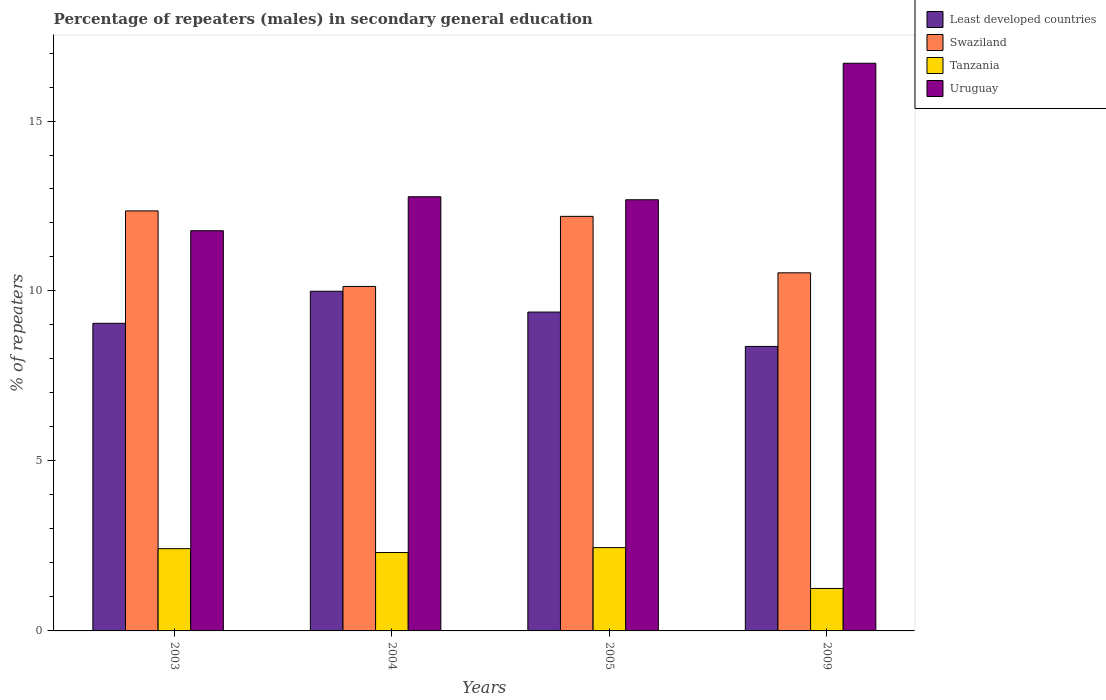How many different coloured bars are there?
Offer a terse response. 4. How many groups of bars are there?
Give a very brief answer. 4. Are the number of bars per tick equal to the number of legend labels?
Your response must be concise. Yes. How many bars are there on the 3rd tick from the right?
Offer a very short reply. 4. What is the label of the 1st group of bars from the left?
Your answer should be compact. 2003. In how many cases, is the number of bars for a given year not equal to the number of legend labels?
Provide a succinct answer. 0. What is the percentage of male repeaters in Least developed countries in 2009?
Give a very brief answer. 8.37. Across all years, what is the maximum percentage of male repeaters in Swaziland?
Ensure brevity in your answer.  12.36. Across all years, what is the minimum percentage of male repeaters in Least developed countries?
Ensure brevity in your answer.  8.37. What is the total percentage of male repeaters in Least developed countries in the graph?
Provide a succinct answer. 36.79. What is the difference between the percentage of male repeaters in Least developed countries in 2003 and that in 2005?
Your answer should be compact. -0.33. What is the difference between the percentage of male repeaters in Uruguay in 2003 and the percentage of male repeaters in Least developed countries in 2004?
Your response must be concise. 1.78. What is the average percentage of male repeaters in Swaziland per year?
Provide a succinct answer. 11.3. In the year 2003, what is the difference between the percentage of male repeaters in Least developed countries and percentage of male repeaters in Tanzania?
Your answer should be compact. 6.63. What is the ratio of the percentage of male repeaters in Uruguay in 2003 to that in 2004?
Make the answer very short. 0.92. Is the percentage of male repeaters in Least developed countries in 2003 less than that in 2009?
Give a very brief answer. No. Is the difference between the percentage of male repeaters in Least developed countries in 2004 and 2009 greater than the difference between the percentage of male repeaters in Tanzania in 2004 and 2009?
Make the answer very short. Yes. What is the difference between the highest and the second highest percentage of male repeaters in Tanzania?
Provide a succinct answer. 0.03. What is the difference between the highest and the lowest percentage of male repeaters in Least developed countries?
Offer a terse response. 1.62. In how many years, is the percentage of male repeaters in Tanzania greater than the average percentage of male repeaters in Tanzania taken over all years?
Keep it short and to the point. 3. What does the 1st bar from the left in 2005 represents?
Offer a terse response. Least developed countries. What does the 1st bar from the right in 2003 represents?
Provide a succinct answer. Uruguay. Is it the case that in every year, the sum of the percentage of male repeaters in Swaziland and percentage of male repeaters in Least developed countries is greater than the percentage of male repeaters in Uruguay?
Ensure brevity in your answer.  Yes. How many bars are there?
Your response must be concise. 16. What is the difference between two consecutive major ticks on the Y-axis?
Keep it short and to the point. 5. Does the graph contain any zero values?
Your answer should be compact. No. Does the graph contain grids?
Your answer should be very brief. No. Where does the legend appear in the graph?
Offer a very short reply. Top right. What is the title of the graph?
Make the answer very short. Percentage of repeaters (males) in secondary general education. What is the label or title of the Y-axis?
Your answer should be compact. % of repeaters. What is the % of repeaters of Least developed countries in 2003?
Ensure brevity in your answer.  9.05. What is the % of repeaters of Swaziland in 2003?
Offer a very short reply. 12.36. What is the % of repeaters of Tanzania in 2003?
Your answer should be compact. 2.42. What is the % of repeaters of Uruguay in 2003?
Your response must be concise. 11.77. What is the % of repeaters in Least developed countries in 2004?
Provide a short and direct response. 9.99. What is the % of repeaters of Swaziland in 2004?
Give a very brief answer. 10.13. What is the % of repeaters in Tanzania in 2004?
Provide a succinct answer. 2.31. What is the % of repeaters of Uruguay in 2004?
Make the answer very short. 12.77. What is the % of repeaters of Least developed countries in 2005?
Your answer should be very brief. 9.38. What is the % of repeaters in Swaziland in 2005?
Your response must be concise. 12.2. What is the % of repeaters in Tanzania in 2005?
Keep it short and to the point. 2.45. What is the % of repeaters in Uruguay in 2005?
Provide a short and direct response. 12.68. What is the % of repeaters of Least developed countries in 2009?
Make the answer very short. 8.37. What is the % of repeaters of Swaziland in 2009?
Give a very brief answer. 10.53. What is the % of repeaters of Tanzania in 2009?
Your answer should be very brief. 1.25. What is the % of repeaters in Uruguay in 2009?
Your answer should be compact. 16.7. Across all years, what is the maximum % of repeaters of Least developed countries?
Provide a short and direct response. 9.99. Across all years, what is the maximum % of repeaters in Swaziland?
Provide a succinct answer. 12.36. Across all years, what is the maximum % of repeaters in Tanzania?
Offer a terse response. 2.45. Across all years, what is the maximum % of repeaters in Uruguay?
Make the answer very short. 16.7. Across all years, what is the minimum % of repeaters of Least developed countries?
Offer a terse response. 8.37. Across all years, what is the minimum % of repeaters of Swaziland?
Offer a very short reply. 10.13. Across all years, what is the minimum % of repeaters of Tanzania?
Your answer should be compact. 1.25. Across all years, what is the minimum % of repeaters in Uruguay?
Give a very brief answer. 11.77. What is the total % of repeaters of Least developed countries in the graph?
Make the answer very short. 36.79. What is the total % of repeaters of Swaziland in the graph?
Ensure brevity in your answer.  45.22. What is the total % of repeaters of Tanzania in the graph?
Ensure brevity in your answer.  8.42. What is the total % of repeaters of Uruguay in the graph?
Offer a very short reply. 53.93. What is the difference between the % of repeaters in Least developed countries in 2003 and that in 2004?
Ensure brevity in your answer.  -0.94. What is the difference between the % of repeaters in Swaziland in 2003 and that in 2004?
Keep it short and to the point. 2.22. What is the difference between the % of repeaters in Tanzania in 2003 and that in 2004?
Make the answer very short. 0.11. What is the difference between the % of repeaters in Uruguay in 2003 and that in 2004?
Offer a terse response. -1. What is the difference between the % of repeaters in Least developed countries in 2003 and that in 2005?
Your answer should be very brief. -0.33. What is the difference between the % of repeaters of Swaziland in 2003 and that in 2005?
Ensure brevity in your answer.  0.16. What is the difference between the % of repeaters in Tanzania in 2003 and that in 2005?
Your answer should be very brief. -0.03. What is the difference between the % of repeaters of Uruguay in 2003 and that in 2005?
Provide a short and direct response. -0.91. What is the difference between the % of repeaters of Least developed countries in 2003 and that in 2009?
Provide a succinct answer. 0.68. What is the difference between the % of repeaters of Swaziland in 2003 and that in 2009?
Ensure brevity in your answer.  1.82. What is the difference between the % of repeaters of Tanzania in 2003 and that in 2009?
Offer a very short reply. 1.17. What is the difference between the % of repeaters of Uruguay in 2003 and that in 2009?
Provide a succinct answer. -4.93. What is the difference between the % of repeaters of Least developed countries in 2004 and that in 2005?
Your answer should be compact. 0.61. What is the difference between the % of repeaters of Swaziland in 2004 and that in 2005?
Your answer should be compact. -2.06. What is the difference between the % of repeaters in Tanzania in 2004 and that in 2005?
Your answer should be very brief. -0.14. What is the difference between the % of repeaters of Uruguay in 2004 and that in 2005?
Give a very brief answer. 0.09. What is the difference between the % of repeaters in Least developed countries in 2004 and that in 2009?
Offer a very short reply. 1.62. What is the difference between the % of repeaters in Swaziland in 2004 and that in 2009?
Provide a short and direct response. -0.4. What is the difference between the % of repeaters in Tanzania in 2004 and that in 2009?
Ensure brevity in your answer.  1.06. What is the difference between the % of repeaters in Uruguay in 2004 and that in 2009?
Give a very brief answer. -3.93. What is the difference between the % of repeaters of Least developed countries in 2005 and that in 2009?
Offer a terse response. 1.01. What is the difference between the % of repeaters of Swaziland in 2005 and that in 2009?
Your answer should be compact. 1.66. What is the difference between the % of repeaters of Tanzania in 2005 and that in 2009?
Your answer should be very brief. 1.2. What is the difference between the % of repeaters in Uruguay in 2005 and that in 2009?
Provide a short and direct response. -4.02. What is the difference between the % of repeaters in Least developed countries in 2003 and the % of repeaters in Swaziland in 2004?
Keep it short and to the point. -1.08. What is the difference between the % of repeaters in Least developed countries in 2003 and the % of repeaters in Tanzania in 2004?
Keep it short and to the point. 6.74. What is the difference between the % of repeaters in Least developed countries in 2003 and the % of repeaters in Uruguay in 2004?
Your response must be concise. -3.72. What is the difference between the % of repeaters of Swaziland in 2003 and the % of repeaters of Tanzania in 2004?
Your response must be concise. 10.05. What is the difference between the % of repeaters in Swaziland in 2003 and the % of repeaters in Uruguay in 2004?
Keep it short and to the point. -0.42. What is the difference between the % of repeaters of Tanzania in 2003 and the % of repeaters of Uruguay in 2004?
Your response must be concise. -10.35. What is the difference between the % of repeaters of Least developed countries in 2003 and the % of repeaters of Swaziland in 2005?
Keep it short and to the point. -3.15. What is the difference between the % of repeaters of Least developed countries in 2003 and the % of repeaters of Tanzania in 2005?
Your answer should be very brief. 6.6. What is the difference between the % of repeaters in Least developed countries in 2003 and the % of repeaters in Uruguay in 2005?
Keep it short and to the point. -3.63. What is the difference between the % of repeaters in Swaziland in 2003 and the % of repeaters in Tanzania in 2005?
Your answer should be compact. 9.91. What is the difference between the % of repeaters in Swaziland in 2003 and the % of repeaters in Uruguay in 2005?
Make the answer very short. -0.33. What is the difference between the % of repeaters in Tanzania in 2003 and the % of repeaters in Uruguay in 2005?
Give a very brief answer. -10.26. What is the difference between the % of repeaters of Least developed countries in 2003 and the % of repeaters of Swaziland in 2009?
Offer a very short reply. -1.49. What is the difference between the % of repeaters of Least developed countries in 2003 and the % of repeaters of Tanzania in 2009?
Give a very brief answer. 7.8. What is the difference between the % of repeaters of Least developed countries in 2003 and the % of repeaters of Uruguay in 2009?
Provide a succinct answer. -7.65. What is the difference between the % of repeaters of Swaziland in 2003 and the % of repeaters of Tanzania in 2009?
Your response must be concise. 11.11. What is the difference between the % of repeaters in Swaziland in 2003 and the % of repeaters in Uruguay in 2009?
Give a very brief answer. -4.34. What is the difference between the % of repeaters of Tanzania in 2003 and the % of repeaters of Uruguay in 2009?
Keep it short and to the point. -14.28. What is the difference between the % of repeaters of Least developed countries in 2004 and the % of repeaters of Swaziland in 2005?
Your answer should be very brief. -2.2. What is the difference between the % of repeaters in Least developed countries in 2004 and the % of repeaters in Tanzania in 2005?
Your response must be concise. 7.54. What is the difference between the % of repeaters in Least developed countries in 2004 and the % of repeaters in Uruguay in 2005?
Make the answer very short. -2.69. What is the difference between the % of repeaters of Swaziland in 2004 and the % of repeaters of Tanzania in 2005?
Ensure brevity in your answer.  7.68. What is the difference between the % of repeaters in Swaziland in 2004 and the % of repeaters in Uruguay in 2005?
Your response must be concise. -2.55. What is the difference between the % of repeaters of Tanzania in 2004 and the % of repeaters of Uruguay in 2005?
Offer a terse response. -10.38. What is the difference between the % of repeaters of Least developed countries in 2004 and the % of repeaters of Swaziland in 2009?
Ensure brevity in your answer.  -0.54. What is the difference between the % of repeaters of Least developed countries in 2004 and the % of repeaters of Tanzania in 2009?
Give a very brief answer. 8.74. What is the difference between the % of repeaters of Least developed countries in 2004 and the % of repeaters of Uruguay in 2009?
Make the answer very short. -6.71. What is the difference between the % of repeaters in Swaziland in 2004 and the % of repeaters in Tanzania in 2009?
Your answer should be compact. 8.88. What is the difference between the % of repeaters in Swaziland in 2004 and the % of repeaters in Uruguay in 2009?
Provide a short and direct response. -6.57. What is the difference between the % of repeaters in Tanzania in 2004 and the % of repeaters in Uruguay in 2009?
Your answer should be very brief. -14.39. What is the difference between the % of repeaters of Least developed countries in 2005 and the % of repeaters of Swaziland in 2009?
Give a very brief answer. -1.15. What is the difference between the % of repeaters of Least developed countries in 2005 and the % of repeaters of Tanzania in 2009?
Give a very brief answer. 8.13. What is the difference between the % of repeaters of Least developed countries in 2005 and the % of repeaters of Uruguay in 2009?
Give a very brief answer. -7.32. What is the difference between the % of repeaters in Swaziland in 2005 and the % of repeaters in Tanzania in 2009?
Offer a very short reply. 10.95. What is the difference between the % of repeaters of Swaziland in 2005 and the % of repeaters of Uruguay in 2009?
Your answer should be compact. -4.5. What is the difference between the % of repeaters in Tanzania in 2005 and the % of repeaters in Uruguay in 2009?
Give a very brief answer. -14.25. What is the average % of repeaters in Least developed countries per year?
Your response must be concise. 9.2. What is the average % of repeaters in Swaziland per year?
Your answer should be very brief. 11.3. What is the average % of repeaters of Tanzania per year?
Provide a short and direct response. 2.11. What is the average % of repeaters of Uruguay per year?
Provide a succinct answer. 13.48. In the year 2003, what is the difference between the % of repeaters in Least developed countries and % of repeaters in Swaziland?
Give a very brief answer. -3.31. In the year 2003, what is the difference between the % of repeaters in Least developed countries and % of repeaters in Tanzania?
Provide a short and direct response. 6.63. In the year 2003, what is the difference between the % of repeaters of Least developed countries and % of repeaters of Uruguay?
Ensure brevity in your answer.  -2.72. In the year 2003, what is the difference between the % of repeaters of Swaziland and % of repeaters of Tanzania?
Offer a very short reply. 9.94. In the year 2003, what is the difference between the % of repeaters of Swaziland and % of repeaters of Uruguay?
Your answer should be compact. 0.58. In the year 2003, what is the difference between the % of repeaters of Tanzania and % of repeaters of Uruguay?
Ensure brevity in your answer.  -9.35. In the year 2004, what is the difference between the % of repeaters of Least developed countries and % of repeaters of Swaziland?
Your answer should be compact. -0.14. In the year 2004, what is the difference between the % of repeaters of Least developed countries and % of repeaters of Tanzania?
Keep it short and to the point. 7.69. In the year 2004, what is the difference between the % of repeaters in Least developed countries and % of repeaters in Uruguay?
Your response must be concise. -2.78. In the year 2004, what is the difference between the % of repeaters of Swaziland and % of repeaters of Tanzania?
Your answer should be very brief. 7.83. In the year 2004, what is the difference between the % of repeaters of Swaziland and % of repeaters of Uruguay?
Your answer should be compact. -2.64. In the year 2004, what is the difference between the % of repeaters in Tanzania and % of repeaters in Uruguay?
Give a very brief answer. -10.47. In the year 2005, what is the difference between the % of repeaters in Least developed countries and % of repeaters in Swaziland?
Offer a very short reply. -2.82. In the year 2005, what is the difference between the % of repeaters in Least developed countries and % of repeaters in Tanzania?
Provide a succinct answer. 6.93. In the year 2005, what is the difference between the % of repeaters in Least developed countries and % of repeaters in Uruguay?
Offer a very short reply. -3.3. In the year 2005, what is the difference between the % of repeaters of Swaziland and % of repeaters of Tanzania?
Make the answer very short. 9.75. In the year 2005, what is the difference between the % of repeaters in Swaziland and % of repeaters in Uruguay?
Give a very brief answer. -0.49. In the year 2005, what is the difference between the % of repeaters in Tanzania and % of repeaters in Uruguay?
Your answer should be very brief. -10.23. In the year 2009, what is the difference between the % of repeaters of Least developed countries and % of repeaters of Swaziland?
Keep it short and to the point. -2.17. In the year 2009, what is the difference between the % of repeaters of Least developed countries and % of repeaters of Tanzania?
Your answer should be very brief. 7.12. In the year 2009, what is the difference between the % of repeaters in Least developed countries and % of repeaters in Uruguay?
Keep it short and to the point. -8.33. In the year 2009, what is the difference between the % of repeaters in Swaziland and % of repeaters in Tanzania?
Your answer should be compact. 9.29. In the year 2009, what is the difference between the % of repeaters in Swaziland and % of repeaters in Uruguay?
Give a very brief answer. -6.16. In the year 2009, what is the difference between the % of repeaters in Tanzania and % of repeaters in Uruguay?
Keep it short and to the point. -15.45. What is the ratio of the % of repeaters in Least developed countries in 2003 to that in 2004?
Give a very brief answer. 0.91. What is the ratio of the % of repeaters in Swaziland in 2003 to that in 2004?
Make the answer very short. 1.22. What is the ratio of the % of repeaters of Tanzania in 2003 to that in 2004?
Provide a succinct answer. 1.05. What is the ratio of the % of repeaters of Uruguay in 2003 to that in 2004?
Your answer should be very brief. 0.92. What is the ratio of the % of repeaters in Least developed countries in 2003 to that in 2005?
Offer a terse response. 0.96. What is the ratio of the % of repeaters of Swaziland in 2003 to that in 2005?
Ensure brevity in your answer.  1.01. What is the ratio of the % of repeaters of Uruguay in 2003 to that in 2005?
Keep it short and to the point. 0.93. What is the ratio of the % of repeaters of Least developed countries in 2003 to that in 2009?
Your answer should be compact. 1.08. What is the ratio of the % of repeaters of Swaziland in 2003 to that in 2009?
Keep it short and to the point. 1.17. What is the ratio of the % of repeaters of Tanzania in 2003 to that in 2009?
Your response must be concise. 1.94. What is the ratio of the % of repeaters of Uruguay in 2003 to that in 2009?
Offer a very short reply. 0.7. What is the ratio of the % of repeaters in Least developed countries in 2004 to that in 2005?
Ensure brevity in your answer.  1.07. What is the ratio of the % of repeaters of Swaziland in 2004 to that in 2005?
Offer a very short reply. 0.83. What is the ratio of the % of repeaters of Tanzania in 2004 to that in 2005?
Keep it short and to the point. 0.94. What is the ratio of the % of repeaters of Least developed countries in 2004 to that in 2009?
Keep it short and to the point. 1.19. What is the ratio of the % of repeaters of Swaziland in 2004 to that in 2009?
Your answer should be compact. 0.96. What is the ratio of the % of repeaters of Tanzania in 2004 to that in 2009?
Provide a succinct answer. 1.85. What is the ratio of the % of repeaters in Uruguay in 2004 to that in 2009?
Ensure brevity in your answer.  0.76. What is the ratio of the % of repeaters in Least developed countries in 2005 to that in 2009?
Give a very brief answer. 1.12. What is the ratio of the % of repeaters of Swaziland in 2005 to that in 2009?
Give a very brief answer. 1.16. What is the ratio of the % of repeaters in Tanzania in 2005 to that in 2009?
Offer a very short reply. 1.96. What is the ratio of the % of repeaters of Uruguay in 2005 to that in 2009?
Keep it short and to the point. 0.76. What is the difference between the highest and the second highest % of repeaters in Least developed countries?
Give a very brief answer. 0.61. What is the difference between the highest and the second highest % of repeaters in Swaziland?
Provide a short and direct response. 0.16. What is the difference between the highest and the second highest % of repeaters in Tanzania?
Ensure brevity in your answer.  0.03. What is the difference between the highest and the second highest % of repeaters in Uruguay?
Offer a very short reply. 3.93. What is the difference between the highest and the lowest % of repeaters in Least developed countries?
Provide a succinct answer. 1.62. What is the difference between the highest and the lowest % of repeaters in Swaziland?
Offer a very short reply. 2.22. What is the difference between the highest and the lowest % of repeaters in Tanzania?
Provide a short and direct response. 1.2. What is the difference between the highest and the lowest % of repeaters in Uruguay?
Offer a very short reply. 4.93. 